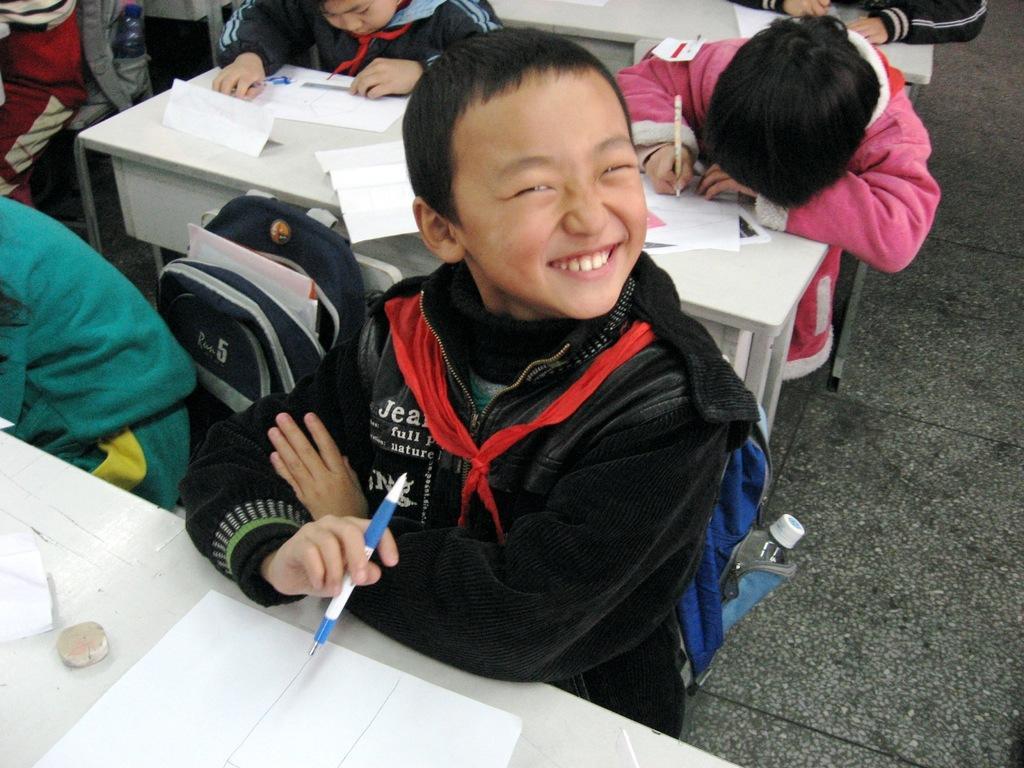Could you give a brief overview of what you see in this image? In this image, I can see a boy sitting and smiling. There are few kids sitting. These are the papers on the tables. I can see the backpack bags. I can see a kid writing. This is the floor. I can see a water bottle, which is kept in the bag. 